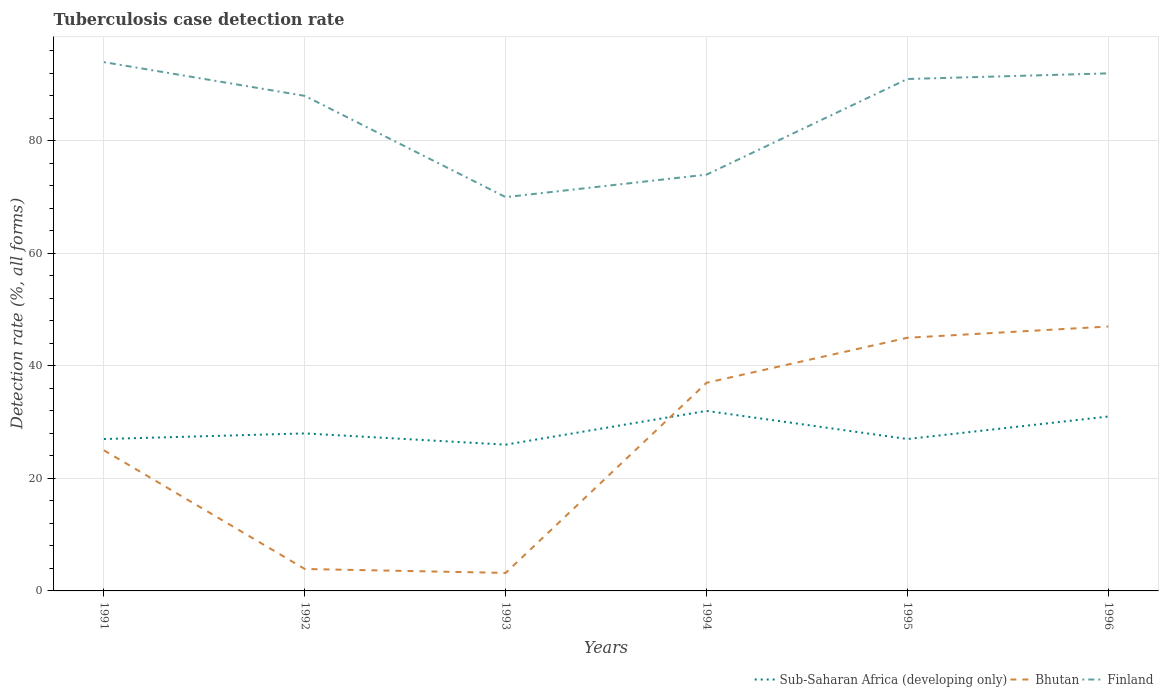How many different coloured lines are there?
Ensure brevity in your answer.  3. Does the line corresponding to Bhutan intersect with the line corresponding to Sub-Saharan Africa (developing only)?
Your answer should be compact. Yes. Is the number of lines equal to the number of legend labels?
Your answer should be compact. Yes. What is the total tuberculosis case detection rate in in Bhutan in the graph?
Keep it short and to the point. 21.8. What is the difference between the highest and the second highest tuberculosis case detection rate in in Finland?
Offer a terse response. 24. Is the tuberculosis case detection rate in in Sub-Saharan Africa (developing only) strictly greater than the tuberculosis case detection rate in in Finland over the years?
Ensure brevity in your answer.  Yes. How many lines are there?
Your answer should be very brief. 3. What is the difference between two consecutive major ticks on the Y-axis?
Make the answer very short. 20. How are the legend labels stacked?
Your response must be concise. Horizontal. What is the title of the graph?
Make the answer very short. Tuberculosis case detection rate. What is the label or title of the X-axis?
Give a very brief answer. Years. What is the label or title of the Y-axis?
Provide a short and direct response. Detection rate (%, all forms). What is the Detection rate (%, all forms) in Sub-Saharan Africa (developing only) in 1991?
Provide a succinct answer. 27. What is the Detection rate (%, all forms) in Finland in 1991?
Your response must be concise. 94. What is the Detection rate (%, all forms) in Sub-Saharan Africa (developing only) in 1992?
Give a very brief answer. 28. What is the Detection rate (%, all forms) of Bhutan in 1992?
Provide a short and direct response. 3.9. What is the Detection rate (%, all forms) of Finland in 1992?
Offer a very short reply. 88. What is the Detection rate (%, all forms) of Sub-Saharan Africa (developing only) in 1993?
Make the answer very short. 26. What is the Detection rate (%, all forms) in Finland in 1993?
Your response must be concise. 70. What is the Detection rate (%, all forms) in Bhutan in 1994?
Provide a short and direct response. 37. What is the Detection rate (%, all forms) in Finland in 1994?
Your answer should be very brief. 74. What is the Detection rate (%, all forms) of Bhutan in 1995?
Your response must be concise. 45. What is the Detection rate (%, all forms) in Finland in 1995?
Give a very brief answer. 91. What is the Detection rate (%, all forms) in Sub-Saharan Africa (developing only) in 1996?
Make the answer very short. 31. What is the Detection rate (%, all forms) in Bhutan in 1996?
Make the answer very short. 47. What is the Detection rate (%, all forms) in Finland in 1996?
Provide a short and direct response. 92. Across all years, what is the maximum Detection rate (%, all forms) in Sub-Saharan Africa (developing only)?
Provide a short and direct response. 32. Across all years, what is the maximum Detection rate (%, all forms) in Finland?
Give a very brief answer. 94. Across all years, what is the minimum Detection rate (%, all forms) of Finland?
Offer a very short reply. 70. What is the total Detection rate (%, all forms) of Sub-Saharan Africa (developing only) in the graph?
Offer a terse response. 171. What is the total Detection rate (%, all forms) in Bhutan in the graph?
Your answer should be compact. 161.1. What is the total Detection rate (%, all forms) of Finland in the graph?
Your answer should be very brief. 509. What is the difference between the Detection rate (%, all forms) of Bhutan in 1991 and that in 1992?
Ensure brevity in your answer.  21.1. What is the difference between the Detection rate (%, all forms) in Finland in 1991 and that in 1992?
Offer a terse response. 6. What is the difference between the Detection rate (%, all forms) in Bhutan in 1991 and that in 1993?
Offer a terse response. 21.8. What is the difference between the Detection rate (%, all forms) of Finland in 1991 and that in 1993?
Give a very brief answer. 24. What is the difference between the Detection rate (%, all forms) of Finland in 1991 and that in 1994?
Keep it short and to the point. 20. What is the difference between the Detection rate (%, all forms) of Sub-Saharan Africa (developing only) in 1991 and that in 1995?
Give a very brief answer. 0. What is the difference between the Detection rate (%, all forms) of Sub-Saharan Africa (developing only) in 1991 and that in 1996?
Your response must be concise. -4. What is the difference between the Detection rate (%, all forms) in Finland in 1991 and that in 1996?
Offer a terse response. 2. What is the difference between the Detection rate (%, all forms) in Sub-Saharan Africa (developing only) in 1992 and that in 1993?
Your answer should be compact. 2. What is the difference between the Detection rate (%, all forms) in Bhutan in 1992 and that in 1994?
Keep it short and to the point. -33.1. What is the difference between the Detection rate (%, all forms) of Finland in 1992 and that in 1994?
Offer a very short reply. 14. What is the difference between the Detection rate (%, all forms) of Bhutan in 1992 and that in 1995?
Give a very brief answer. -41.1. What is the difference between the Detection rate (%, all forms) of Sub-Saharan Africa (developing only) in 1992 and that in 1996?
Make the answer very short. -3. What is the difference between the Detection rate (%, all forms) of Bhutan in 1992 and that in 1996?
Give a very brief answer. -43.1. What is the difference between the Detection rate (%, all forms) in Bhutan in 1993 and that in 1994?
Provide a short and direct response. -33.8. What is the difference between the Detection rate (%, all forms) in Finland in 1993 and that in 1994?
Keep it short and to the point. -4. What is the difference between the Detection rate (%, all forms) in Sub-Saharan Africa (developing only) in 1993 and that in 1995?
Your answer should be very brief. -1. What is the difference between the Detection rate (%, all forms) in Bhutan in 1993 and that in 1995?
Your response must be concise. -41.8. What is the difference between the Detection rate (%, all forms) of Bhutan in 1993 and that in 1996?
Offer a terse response. -43.8. What is the difference between the Detection rate (%, all forms) of Finland in 1994 and that in 1995?
Provide a succinct answer. -17. What is the difference between the Detection rate (%, all forms) of Bhutan in 1995 and that in 1996?
Ensure brevity in your answer.  -2. What is the difference between the Detection rate (%, all forms) in Finland in 1995 and that in 1996?
Offer a very short reply. -1. What is the difference between the Detection rate (%, all forms) in Sub-Saharan Africa (developing only) in 1991 and the Detection rate (%, all forms) in Bhutan in 1992?
Provide a short and direct response. 23.1. What is the difference between the Detection rate (%, all forms) of Sub-Saharan Africa (developing only) in 1991 and the Detection rate (%, all forms) of Finland in 1992?
Offer a very short reply. -61. What is the difference between the Detection rate (%, all forms) in Bhutan in 1991 and the Detection rate (%, all forms) in Finland in 1992?
Your answer should be very brief. -63. What is the difference between the Detection rate (%, all forms) of Sub-Saharan Africa (developing only) in 1991 and the Detection rate (%, all forms) of Bhutan in 1993?
Offer a very short reply. 23.8. What is the difference between the Detection rate (%, all forms) of Sub-Saharan Africa (developing only) in 1991 and the Detection rate (%, all forms) of Finland in 1993?
Your response must be concise. -43. What is the difference between the Detection rate (%, all forms) in Bhutan in 1991 and the Detection rate (%, all forms) in Finland in 1993?
Keep it short and to the point. -45. What is the difference between the Detection rate (%, all forms) in Sub-Saharan Africa (developing only) in 1991 and the Detection rate (%, all forms) in Finland in 1994?
Your response must be concise. -47. What is the difference between the Detection rate (%, all forms) in Bhutan in 1991 and the Detection rate (%, all forms) in Finland in 1994?
Your answer should be compact. -49. What is the difference between the Detection rate (%, all forms) of Sub-Saharan Africa (developing only) in 1991 and the Detection rate (%, all forms) of Bhutan in 1995?
Ensure brevity in your answer.  -18. What is the difference between the Detection rate (%, all forms) of Sub-Saharan Africa (developing only) in 1991 and the Detection rate (%, all forms) of Finland in 1995?
Keep it short and to the point. -64. What is the difference between the Detection rate (%, all forms) in Bhutan in 1991 and the Detection rate (%, all forms) in Finland in 1995?
Offer a terse response. -66. What is the difference between the Detection rate (%, all forms) of Sub-Saharan Africa (developing only) in 1991 and the Detection rate (%, all forms) of Finland in 1996?
Provide a succinct answer. -65. What is the difference between the Detection rate (%, all forms) in Bhutan in 1991 and the Detection rate (%, all forms) in Finland in 1996?
Give a very brief answer. -67. What is the difference between the Detection rate (%, all forms) in Sub-Saharan Africa (developing only) in 1992 and the Detection rate (%, all forms) in Bhutan in 1993?
Your answer should be compact. 24.8. What is the difference between the Detection rate (%, all forms) in Sub-Saharan Africa (developing only) in 1992 and the Detection rate (%, all forms) in Finland in 1993?
Your response must be concise. -42. What is the difference between the Detection rate (%, all forms) in Bhutan in 1992 and the Detection rate (%, all forms) in Finland in 1993?
Offer a terse response. -66.1. What is the difference between the Detection rate (%, all forms) of Sub-Saharan Africa (developing only) in 1992 and the Detection rate (%, all forms) of Finland in 1994?
Provide a succinct answer. -46. What is the difference between the Detection rate (%, all forms) of Bhutan in 1992 and the Detection rate (%, all forms) of Finland in 1994?
Make the answer very short. -70.1. What is the difference between the Detection rate (%, all forms) of Sub-Saharan Africa (developing only) in 1992 and the Detection rate (%, all forms) of Bhutan in 1995?
Offer a very short reply. -17. What is the difference between the Detection rate (%, all forms) of Sub-Saharan Africa (developing only) in 1992 and the Detection rate (%, all forms) of Finland in 1995?
Your response must be concise. -63. What is the difference between the Detection rate (%, all forms) in Bhutan in 1992 and the Detection rate (%, all forms) in Finland in 1995?
Provide a short and direct response. -87.1. What is the difference between the Detection rate (%, all forms) of Sub-Saharan Africa (developing only) in 1992 and the Detection rate (%, all forms) of Bhutan in 1996?
Provide a short and direct response. -19. What is the difference between the Detection rate (%, all forms) of Sub-Saharan Africa (developing only) in 1992 and the Detection rate (%, all forms) of Finland in 1996?
Offer a very short reply. -64. What is the difference between the Detection rate (%, all forms) of Bhutan in 1992 and the Detection rate (%, all forms) of Finland in 1996?
Your response must be concise. -88.1. What is the difference between the Detection rate (%, all forms) in Sub-Saharan Africa (developing only) in 1993 and the Detection rate (%, all forms) in Bhutan in 1994?
Your answer should be compact. -11. What is the difference between the Detection rate (%, all forms) in Sub-Saharan Africa (developing only) in 1993 and the Detection rate (%, all forms) in Finland in 1994?
Keep it short and to the point. -48. What is the difference between the Detection rate (%, all forms) of Bhutan in 1993 and the Detection rate (%, all forms) of Finland in 1994?
Provide a short and direct response. -70.8. What is the difference between the Detection rate (%, all forms) of Sub-Saharan Africa (developing only) in 1993 and the Detection rate (%, all forms) of Finland in 1995?
Your answer should be very brief. -65. What is the difference between the Detection rate (%, all forms) of Bhutan in 1993 and the Detection rate (%, all forms) of Finland in 1995?
Your answer should be compact. -87.8. What is the difference between the Detection rate (%, all forms) in Sub-Saharan Africa (developing only) in 1993 and the Detection rate (%, all forms) in Finland in 1996?
Offer a terse response. -66. What is the difference between the Detection rate (%, all forms) of Bhutan in 1993 and the Detection rate (%, all forms) of Finland in 1996?
Offer a very short reply. -88.8. What is the difference between the Detection rate (%, all forms) in Sub-Saharan Africa (developing only) in 1994 and the Detection rate (%, all forms) in Bhutan in 1995?
Give a very brief answer. -13. What is the difference between the Detection rate (%, all forms) in Sub-Saharan Africa (developing only) in 1994 and the Detection rate (%, all forms) in Finland in 1995?
Your answer should be compact. -59. What is the difference between the Detection rate (%, all forms) of Bhutan in 1994 and the Detection rate (%, all forms) of Finland in 1995?
Your answer should be compact. -54. What is the difference between the Detection rate (%, all forms) in Sub-Saharan Africa (developing only) in 1994 and the Detection rate (%, all forms) in Bhutan in 1996?
Give a very brief answer. -15. What is the difference between the Detection rate (%, all forms) in Sub-Saharan Africa (developing only) in 1994 and the Detection rate (%, all forms) in Finland in 1996?
Ensure brevity in your answer.  -60. What is the difference between the Detection rate (%, all forms) in Bhutan in 1994 and the Detection rate (%, all forms) in Finland in 1996?
Provide a succinct answer. -55. What is the difference between the Detection rate (%, all forms) of Sub-Saharan Africa (developing only) in 1995 and the Detection rate (%, all forms) of Bhutan in 1996?
Offer a terse response. -20. What is the difference between the Detection rate (%, all forms) in Sub-Saharan Africa (developing only) in 1995 and the Detection rate (%, all forms) in Finland in 1996?
Your answer should be compact. -65. What is the difference between the Detection rate (%, all forms) in Bhutan in 1995 and the Detection rate (%, all forms) in Finland in 1996?
Offer a very short reply. -47. What is the average Detection rate (%, all forms) of Bhutan per year?
Keep it short and to the point. 26.85. What is the average Detection rate (%, all forms) of Finland per year?
Provide a succinct answer. 84.83. In the year 1991, what is the difference between the Detection rate (%, all forms) in Sub-Saharan Africa (developing only) and Detection rate (%, all forms) in Finland?
Your response must be concise. -67. In the year 1991, what is the difference between the Detection rate (%, all forms) in Bhutan and Detection rate (%, all forms) in Finland?
Offer a very short reply. -69. In the year 1992, what is the difference between the Detection rate (%, all forms) in Sub-Saharan Africa (developing only) and Detection rate (%, all forms) in Bhutan?
Offer a terse response. 24.1. In the year 1992, what is the difference between the Detection rate (%, all forms) of Sub-Saharan Africa (developing only) and Detection rate (%, all forms) of Finland?
Offer a very short reply. -60. In the year 1992, what is the difference between the Detection rate (%, all forms) in Bhutan and Detection rate (%, all forms) in Finland?
Make the answer very short. -84.1. In the year 1993, what is the difference between the Detection rate (%, all forms) in Sub-Saharan Africa (developing only) and Detection rate (%, all forms) in Bhutan?
Make the answer very short. 22.8. In the year 1993, what is the difference between the Detection rate (%, all forms) of Sub-Saharan Africa (developing only) and Detection rate (%, all forms) of Finland?
Provide a short and direct response. -44. In the year 1993, what is the difference between the Detection rate (%, all forms) of Bhutan and Detection rate (%, all forms) of Finland?
Give a very brief answer. -66.8. In the year 1994, what is the difference between the Detection rate (%, all forms) in Sub-Saharan Africa (developing only) and Detection rate (%, all forms) in Bhutan?
Ensure brevity in your answer.  -5. In the year 1994, what is the difference between the Detection rate (%, all forms) in Sub-Saharan Africa (developing only) and Detection rate (%, all forms) in Finland?
Give a very brief answer. -42. In the year 1994, what is the difference between the Detection rate (%, all forms) in Bhutan and Detection rate (%, all forms) in Finland?
Give a very brief answer. -37. In the year 1995, what is the difference between the Detection rate (%, all forms) in Sub-Saharan Africa (developing only) and Detection rate (%, all forms) in Finland?
Provide a short and direct response. -64. In the year 1995, what is the difference between the Detection rate (%, all forms) of Bhutan and Detection rate (%, all forms) of Finland?
Your answer should be compact. -46. In the year 1996, what is the difference between the Detection rate (%, all forms) of Sub-Saharan Africa (developing only) and Detection rate (%, all forms) of Bhutan?
Provide a succinct answer. -16. In the year 1996, what is the difference between the Detection rate (%, all forms) of Sub-Saharan Africa (developing only) and Detection rate (%, all forms) of Finland?
Your response must be concise. -61. In the year 1996, what is the difference between the Detection rate (%, all forms) in Bhutan and Detection rate (%, all forms) in Finland?
Ensure brevity in your answer.  -45. What is the ratio of the Detection rate (%, all forms) of Bhutan in 1991 to that in 1992?
Offer a very short reply. 6.41. What is the ratio of the Detection rate (%, all forms) of Finland in 1991 to that in 1992?
Your response must be concise. 1.07. What is the ratio of the Detection rate (%, all forms) in Bhutan in 1991 to that in 1993?
Keep it short and to the point. 7.81. What is the ratio of the Detection rate (%, all forms) in Finland in 1991 to that in 1993?
Make the answer very short. 1.34. What is the ratio of the Detection rate (%, all forms) in Sub-Saharan Africa (developing only) in 1991 to that in 1994?
Provide a succinct answer. 0.84. What is the ratio of the Detection rate (%, all forms) in Bhutan in 1991 to that in 1994?
Keep it short and to the point. 0.68. What is the ratio of the Detection rate (%, all forms) in Finland in 1991 to that in 1994?
Give a very brief answer. 1.27. What is the ratio of the Detection rate (%, all forms) in Sub-Saharan Africa (developing only) in 1991 to that in 1995?
Your answer should be very brief. 1. What is the ratio of the Detection rate (%, all forms) of Bhutan in 1991 to that in 1995?
Offer a terse response. 0.56. What is the ratio of the Detection rate (%, all forms) in Finland in 1991 to that in 1995?
Provide a short and direct response. 1.03. What is the ratio of the Detection rate (%, all forms) in Sub-Saharan Africa (developing only) in 1991 to that in 1996?
Provide a short and direct response. 0.87. What is the ratio of the Detection rate (%, all forms) of Bhutan in 1991 to that in 1996?
Your answer should be very brief. 0.53. What is the ratio of the Detection rate (%, all forms) of Finland in 1991 to that in 1996?
Offer a very short reply. 1.02. What is the ratio of the Detection rate (%, all forms) of Bhutan in 1992 to that in 1993?
Offer a very short reply. 1.22. What is the ratio of the Detection rate (%, all forms) of Finland in 1992 to that in 1993?
Offer a very short reply. 1.26. What is the ratio of the Detection rate (%, all forms) of Bhutan in 1992 to that in 1994?
Keep it short and to the point. 0.11. What is the ratio of the Detection rate (%, all forms) of Finland in 1992 to that in 1994?
Your answer should be very brief. 1.19. What is the ratio of the Detection rate (%, all forms) in Bhutan in 1992 to that in 1995?
Give a very brief answer. 0.09. What is the ratio of the Detection rate (%, all forms) in Sub-Saharan Africa (developing only) in 1992 to that in 1996?
Offer a very short reply. 0.9. What is the ratio of the Detection rate (%, all forms) in Bhutan in 1992 to that in 1996?
Keep it short and to the point. 0.08. What is the ratio of the Detection rate (%, all forms) in Finland in 1992 to that in 1996?
Ensure brevity in your answer.  0.96. What is the ratio of the Detection rate (%, all forms) of Sub-Saharan Africa (developing only) in 1993 to that in 1994?
Your response must be concise. 0.81. What is the ratio of the Detection rate (%, all forms) in Bhutan in 1993 to that in 1994?
Keep it short and to the point. 0.09. What is the ratio of the Detection rate (%, all forms) in Finland in 1993 to that in 1994?
Give a very brief answer. 0.95. What is the ratio of the Detection rate (%, all forms) of Bhutan in 1993 to that in 1995?
Your response must be concise. 0.07. What is the ratio of the Detection rate (%, all forms) in Finland in 1993 to that in 1995?
Your answer should be very brief. 0.77. What is the ratio of the Detection rate (%, all forms) of Sub-Saharan Africa (developing only) in 1993 to that in 1996?
Your answer should be very brief. 0.84. What is the ratio of the Detection rate (%, all forms) of Bhutan in 1993 to that in 1996?
Your answer should be very brief. 0.07. What is the ratio of the Detection rate (%, all forms) of Finland in 1993 to that in 1996?
Your answer should be compact. 0.76. What is the ratio of the Detection rate (%, all forms) in Sub-Saharan Africa (developing only) in 1994 to that in 1995?
Make the answer very short. 1.19. What is the ratio of the Detection rate (%, all forms) in Bhutan in 1994 to that in 1995?
Provide a short and direct response. 0.82. What is the ratio of the Detection rate (%, all forms) in Finland in 1994 to that in 1995?
Offer a very short reply. 0.81. What is the ratio of the Detection rate (%, all forms) in Sub-Saharan Africa (developing only) in 1994 to that in 1996?
Offer a terse response. 1.03. What is the ratio of the Detection rate (%, all forms) of Bhutan in 1994 to that in 1996?
Ensure brevity in your answer.  0.79. What is the ratio of the Detection rate (%, all forms) in Finland in 1994 to that in 1996?
Provide a succinct answer. 0.8. What is the ratio of the Detection rate (%, all forms) in Sub-Saharan Africa (developing only) in 1995 to that in 1996?
Offer a very short reply. 0.87. What is the ratio of the Detection rate (%, all forms) of Bhutan in 1995 to that in 1996?
Keep it short and to the point. 0.96. What is the ratio of the Detection rate (%, all forms) in Finland in 1995 to that in 1996?
Your answer should be compact. 0.99. What is the difference between the highest and the second highest Detection rate (%, all forms) of Finland?
Your answer should be compact. 2. What is the difference between the highest and the lowest Detection rate (%, all forms) in Sub-Saharan Africa (developing only)?
Ensure brevity in your answer.  6. What is the difference between the highest and the lowest Detection rate (%, all forms) of Bhutan?
Provide a succinct answer. 43.8. 